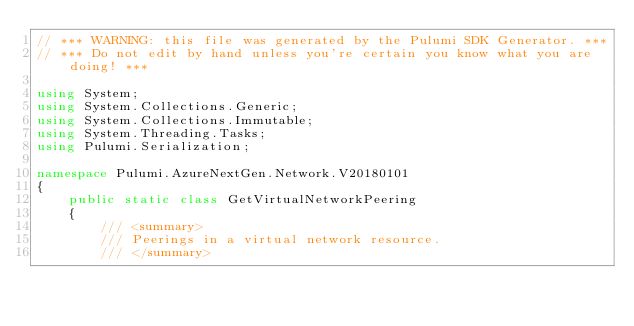<code> <loc_0><loc_0><loc_500><loc_500><_C#_>// *** WARNING: this file was generated by the Pulumi SDK Generator. ***
// *** Do not edit by hand unless you're certain you know what you are doing! ***

using System;
using System.Collections.Generic;
using System.Collections.Immutable;
using System.Threading.Tasks;
using Pulumi.Serialization;

namespace Pulumi.AzureNextGen.Network.V20180101
{
    public static class GetVirtualNetworkPeering
    {
        /// <summary>
        /// Peerings in a virtual network resource.
        /// </summary></code> 